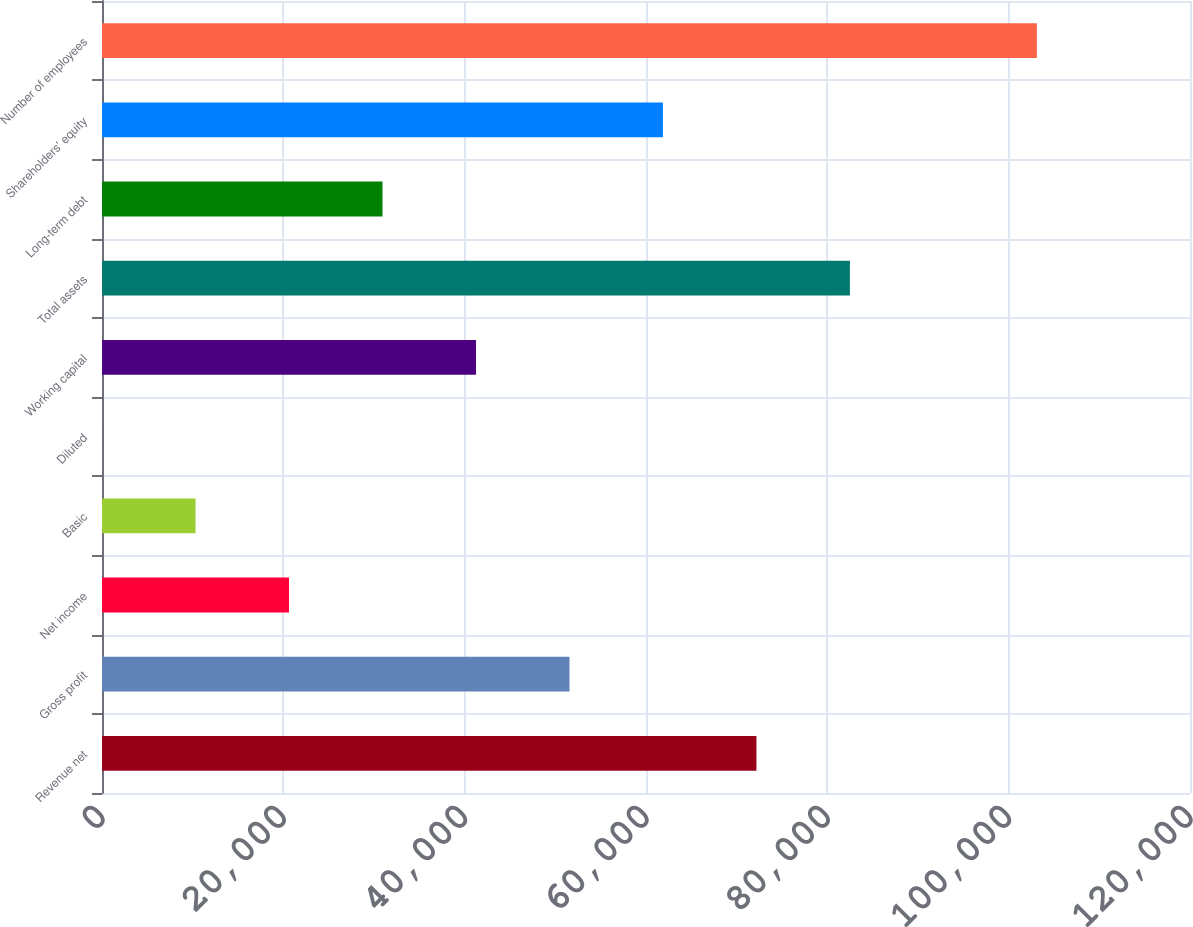<chart> <loc_0><loc_0><loc_500><loc_500><bar_chart><fcel>Revenue net<fcel>Gross profit<fcel>Net income<fcel>Basic<fcel>Diluted<fcel>Working capital<fcel>Total assets<fcel>Long-term debt<fcel>Shareholders' equity<fcel>Number of employees<nl><fcel>72179.7<fcel>51558.8<fcel>20627.5<fcel>10317<fcel>6.58<fcel>41248.3<fcel>82490.1<fcel>30937.9<fcel>61869.2<fcel>103111<nl></chart> 